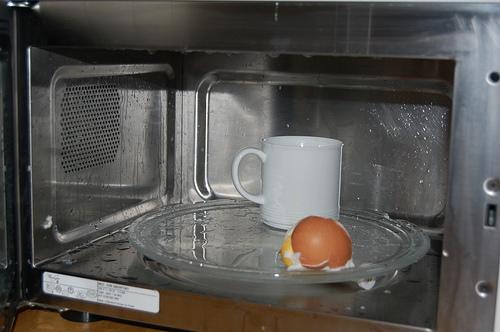What color is the coffee cup?
Concise answer only. White. Is the egg raw?
Quick response, please. Yes. Where is the cup located?
Give a very brief answer. Microwave. 